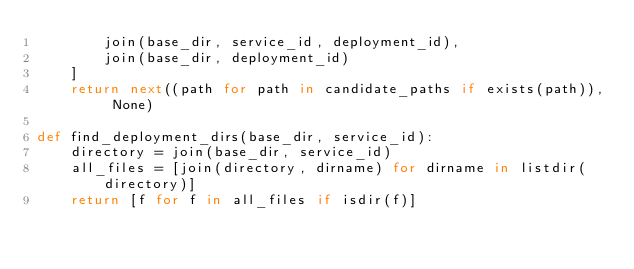Convert code to text. <code><loc_0><loc_0><loc_500><loc_500><_Python_>        join(base_dir, service_id, deployment_id),
        join(base_dir, deployment_id)
    ]
    return next((path for path in candidate_paths if exists(path)), None)

def find_deployment_dirs(base_dir, service_id):
    directory = join(base_dir, service_id)
    all_files = [join(directory, dirname) for dirname in listdir(directory)]
    return [f for f in all_files if isdir(f)]
</code> 